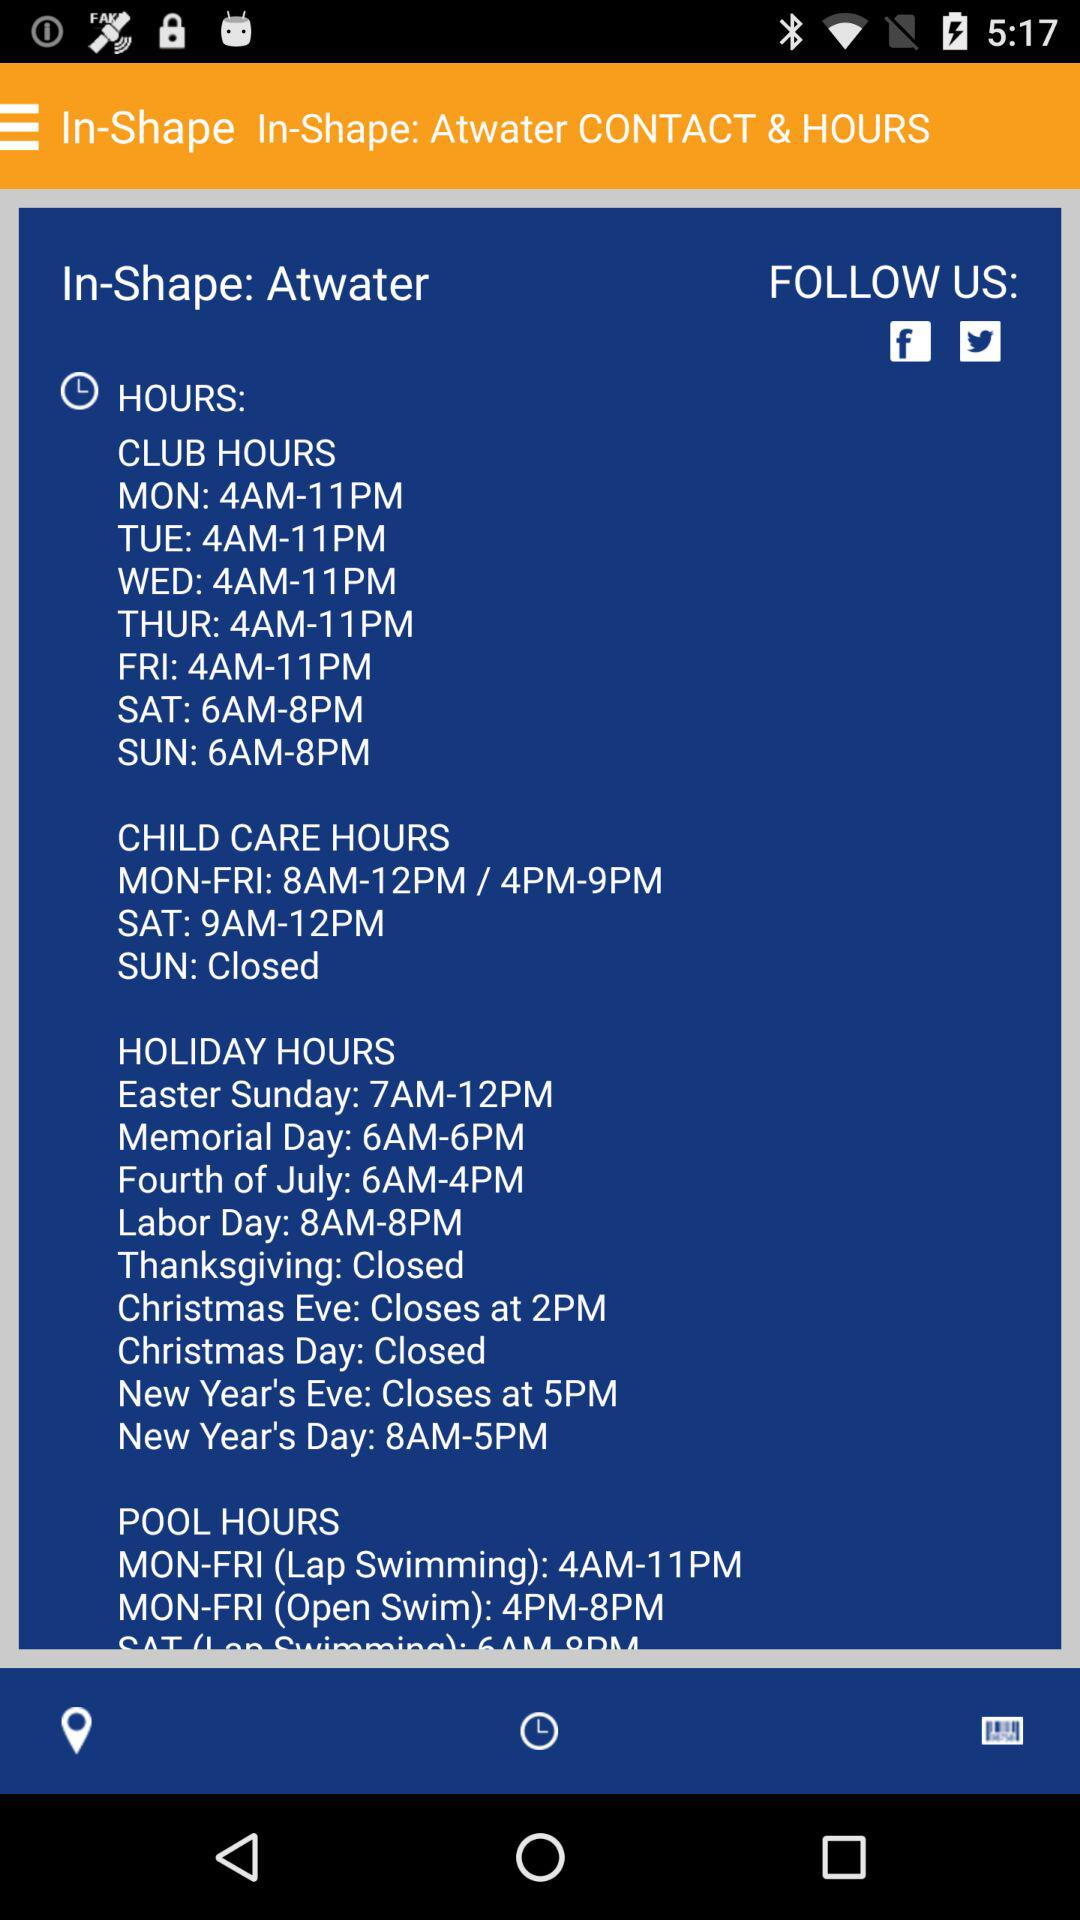What is the timing of club hours on Monday? The timing of club hours on Monday is 4 a.m. to 11 p.m. 